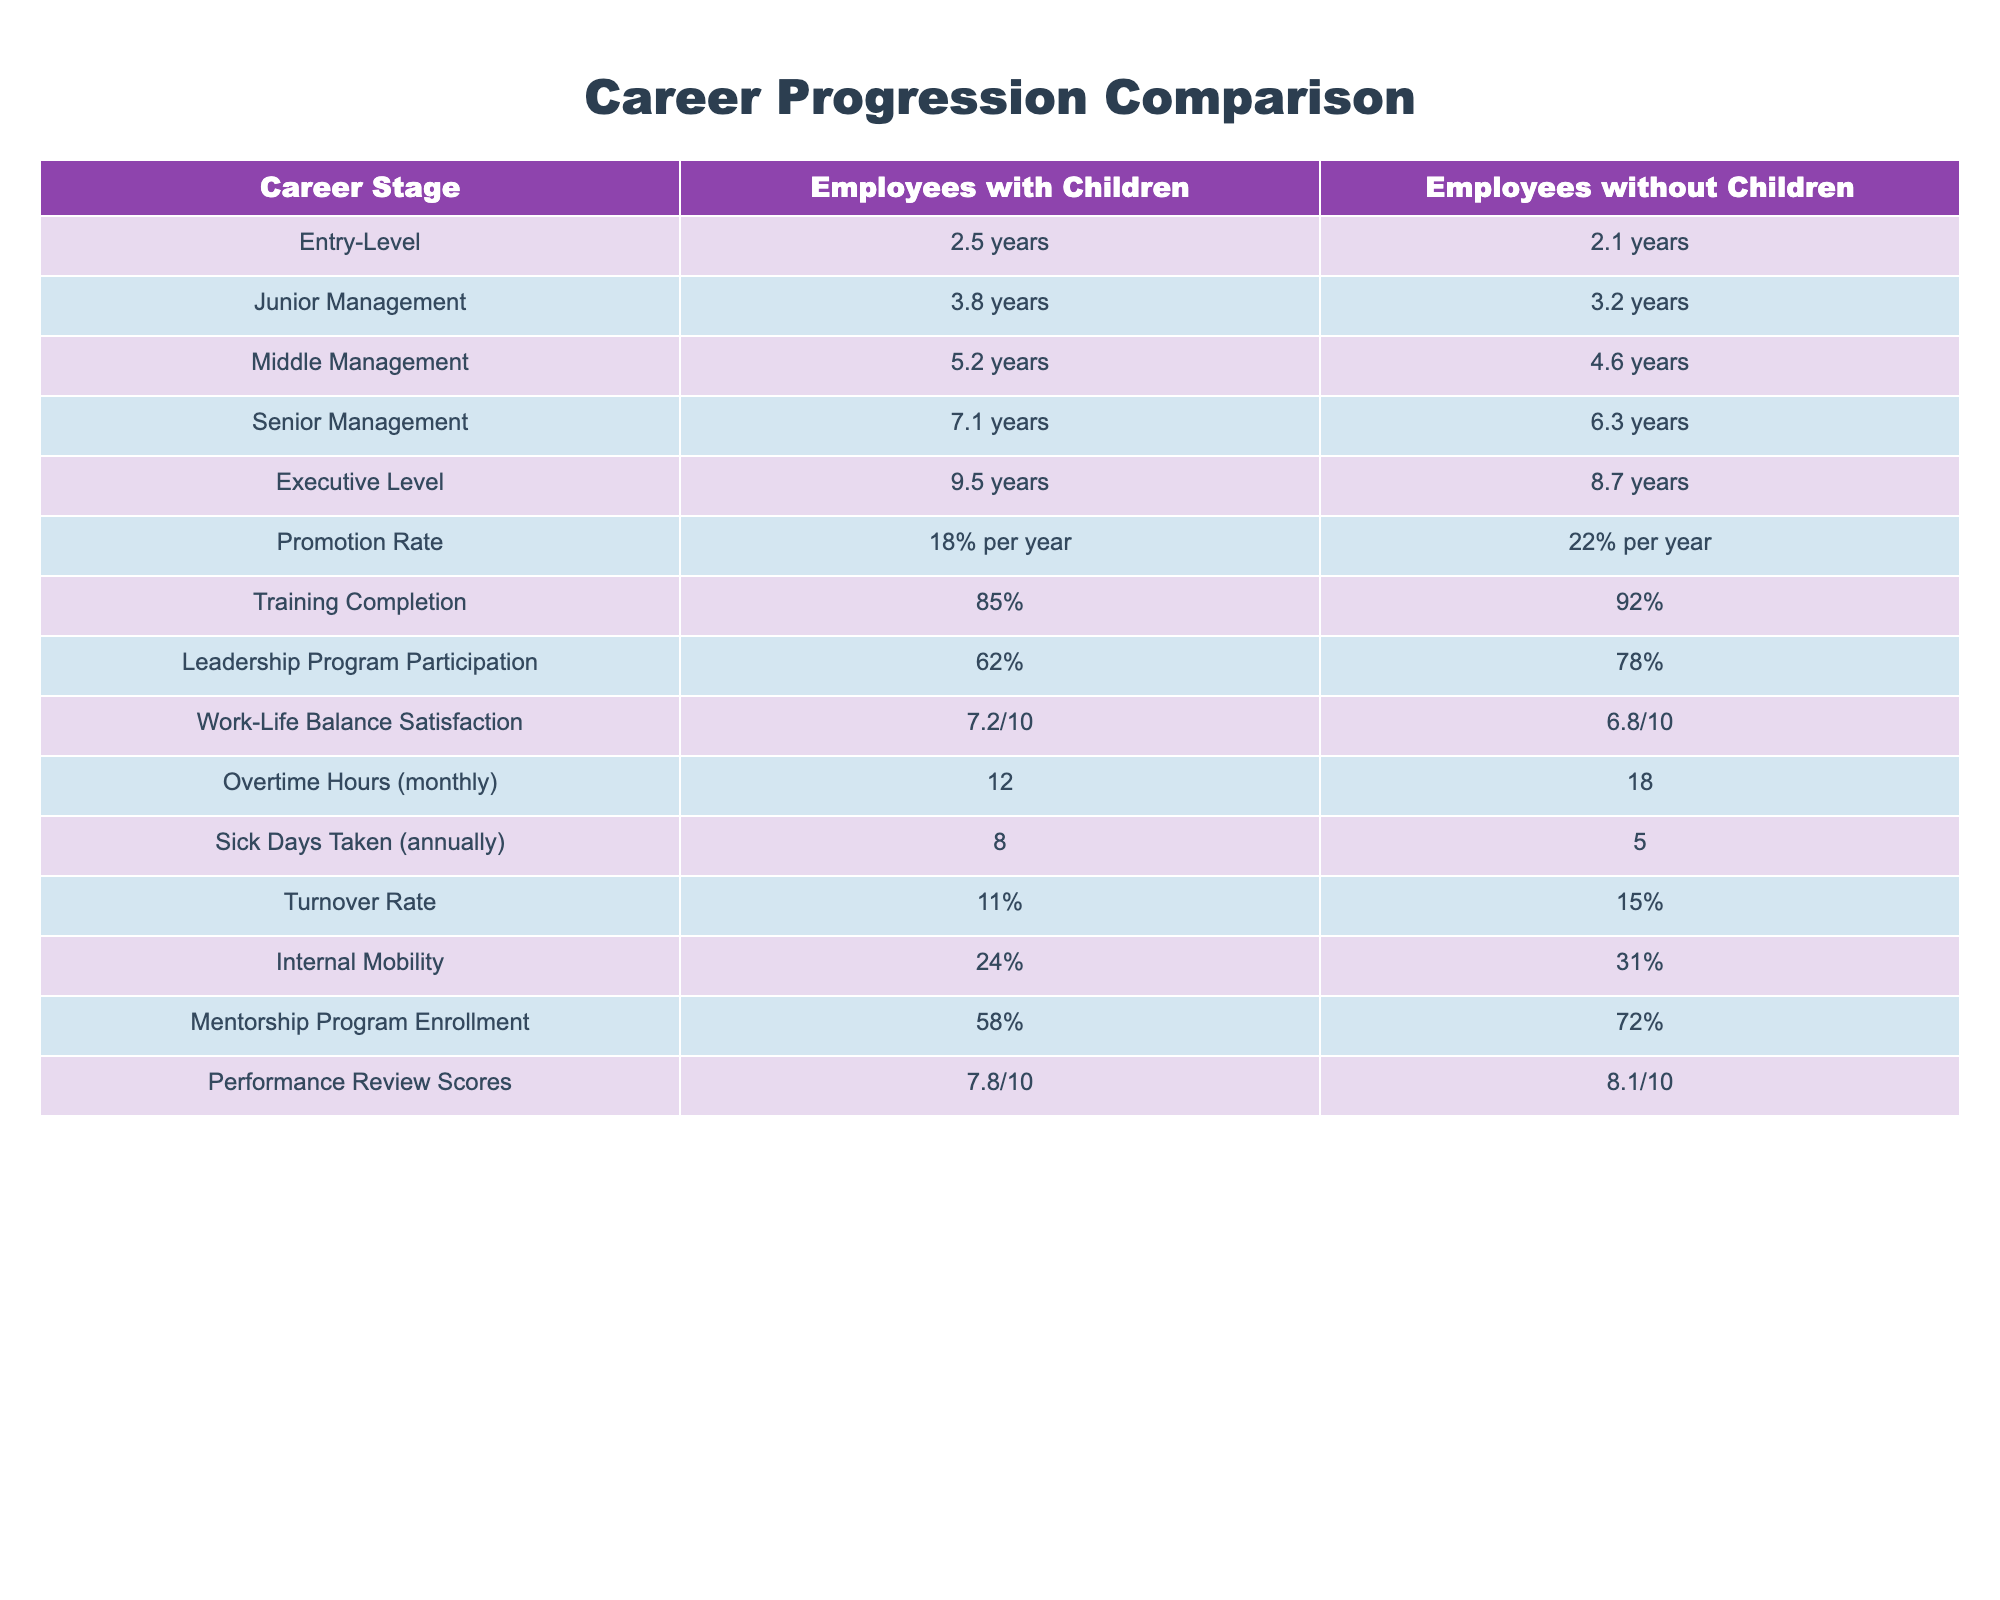What is the average tenure at the Executive Level for employees with children? At the Executive Level, the tenure for employees with children is 9.5 years. Since only one data point exists, the average is the same as the tenure.
Answer: 9.5 years Which group has a higher promotion rate? Employees without children have a promotion rate of 22% per year, while employees with children have a promotion rate of 18% per year. Therefore, employees without children have a higher promotion rate.
Answer: Employees without children What is the difference in monthly overtime hours between the two groups? Employees with children work 12 overtime hours monthly, while those without children work 18 hours. The difference is 18 - 12 = 6 hours.
Answer: 6 hours Do employees with children participate more in the Leadership Program than those without children? Employees with children have a Leadership Program participation rate of 62%, while the rate for those without children is 78%. Therefore, employees with children do not participate more.
Answer: No What is the total number of sick days taken annually by employees with and without children combined? Employees with children take 8 sick days, while employees without children take 5 sick days. The total is 8 + 5 = 13 sick days taken annually.
Answer: 13 sick days What is the relative work-life balance satisfaction score for employees with children compared to those without children? Employees with children have a score of 7.2/10, while those without children have a score of 6.8/10. To find the relative difference, subtract: 7.2 - 6.8 = 0.4. Therefore, employees with children are relatively more satisfied by 0.4 points.
Answer: 0.4 points What percentage of employees with children is enrolled in the Mentorship Program? Employees with children have a Mentorship Program enrollment rate of 58%. This figure can be directly retrieved from the table.
Answer: 58% Which group has a higher performance review score, and what is the difference? Employees with children have a score of 7.8/10, while those without children have a score of 8.1/10. The difference is 8.1 - 7.8 = 0.3, indicating that employees without children have a higher score.
Answer: Employees without children, difference of 0.3 What can be inferred about the turnover rates for employees with children versus those without? Employees with children have a turnover rate of 11%, while employees without children have a higher rate of 15%. This suggests that employees with children tend to have a lower turnover rate.
Answer: Lower turnover rate for employees with children 